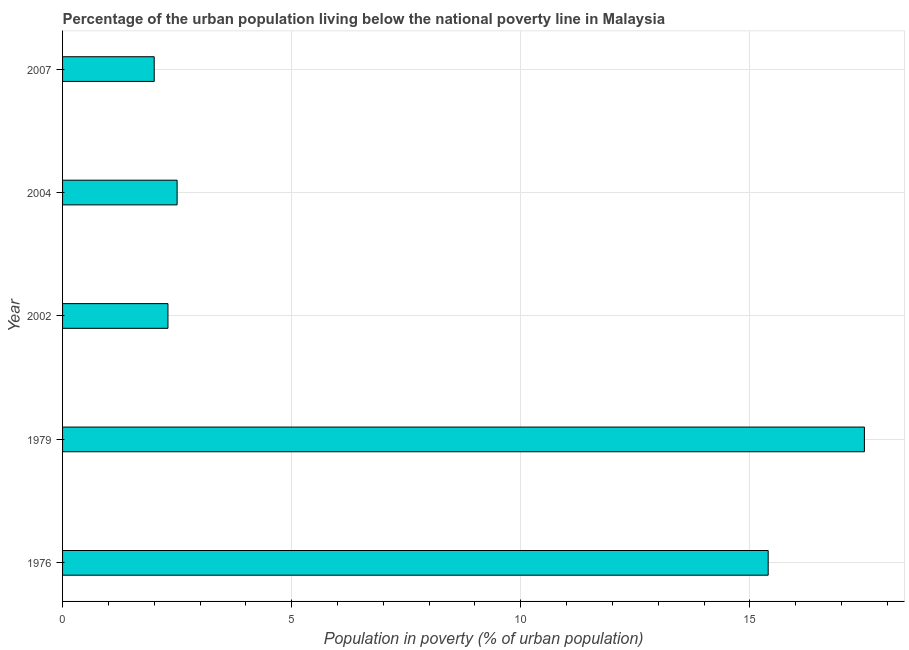Does the graph contain grids?
Offer a terse response. Yes. What is the title of the graph?
Keep it short and to the point. Percentage of the urban population living below the national poverty line in Malaysia. What is the label or title of the X-axis?
Your answer should be very brief. Population in poverty (% of urban population). What is the label or title of the Y-axis?
Your answer should be compact. Year. What is the percentage of urban population living below poverty line in 2002?
Your answer should be compact. 2.3. Across all years, what is the maximum percentage of urban population living below poverty line?
Make the answer very short. 17.5. In which year was the percentage of urban population living below poverty line maximum?
Give a very brief answer. 1979. In which year was the percentage of urban population living below poverty line minimum?
Offer a terse response. 2007. What is the sum of the percentage of urban population living below poverty line?
Keep it short and to the point. 39.7. What is the difference between the percentage of urban population living below poverty line in 1976 and 2004?
Your response must be concise. 12.9. What is the average percentage of urban population living below poverty line per year?
Provide a short and direct response. 7.94. What is the median percentage of urban population living below poverty line?
Give a very brief answer. 2.5. In how many years, is the percentage of urban population living below poverty line greater than 17 %?
Keep it short and to the point. 1. What is the ratio of the percentage of urban population living below poverty line in 1979 to that in 2007?
Provide a succinct answer. 8.75. Is the percentage of urban population living below poverty line in 2004 less than that in 2007?
Provide a short and direct response. No. What is the difference between the highest and the second highest percentage of urban population living below poverty line?
Offer a terse response. 2.1. Is the sum of the percentage of urban population living below poverty line in 1979 and 2004 greater than the maximum percentage of urban population living below poverty line across all years?
Give a very brief answer. Yes. In how many years, is the percentage of urban population living below poverty line greater than the average percentage of urban population living below poverty line taken over all years?
Offer a very short reply. 2. Are all the bars in the graph horizontal?
Ensure brevity in your answer.  Yes. How many years are there in the graph?
Provide a short and direct response. 5. What is the difference between two consecutive major ticks on the X-axis?
Keep it short and to the point. 5. Are the values on the major ticks of X-axis written in scientific E-notation?
Give a very brief answer. No. What is the Population in poverty (% of urban population) of 1979?
Offer a terse response. 17.5. What is the Population in poverty (% of urban population) in 2002?
Give a very brief answer. 2.3. What is the Population in poverty (% of urban population) of 2004?
Ensure brevity in your answer.  2.5. What is the Population in poverty (% of urban population) of 2007?
Make the answer very short. 2. What is the difference between the Population in poverty (% of urban population) in 1976 and 2004?
Your response must be concise. 12.9. What is the difference between the Population in poverty (% of urban population) in 1979 and 2002?
Offer a very short reply. 15.2. What is the difference between the Population in poverty (% of urban population) in 1979 and 2004?
Your answer should be very brief. 15. What is the difference between the Population in poverty (% of urban population) in 2002 and 2004?
Provide a succinct answer. -0.2. What is the difference between the Population in poverty (% of urban population) in 2002 and 2007?
Your answer should be compact. 0.3. What is the difference between the Population in poverty (% of urban population) in 2004 and 2007?
Provide a short and direct response. 0.5. What is the ratio of the Population in poverty (% of urban population) in 1976 to that in 1979?
Ensure brevity in your answer.  0.88. What is the ratio of the Population in poverty (% of urban population) in 1976 to that in 2002?
Your response must be concise. 6.7. What is the ratio of the Population in poverty (% of urban population) in 1976 to that in 2004?
Your answer should be very brief. 6.16. What is the ratio of the Population in poverty (% of urban population) in 1976 to that in 2007?
Your answer should be compact. 7.7. What is the ratio of the Population in poverty (% of urban population) in 1979 to that in 2002?
Provide a short and direct response. 7.61. What is the ratio of the Population in poverty (% of urban population) in 1979 to that in 2007?
Keep it short and to the point. 8.75. What is the ratio of the Population in poverty (% of urban population) in 2002 to that in 2007?
Offer a very short reply. 1.15. 